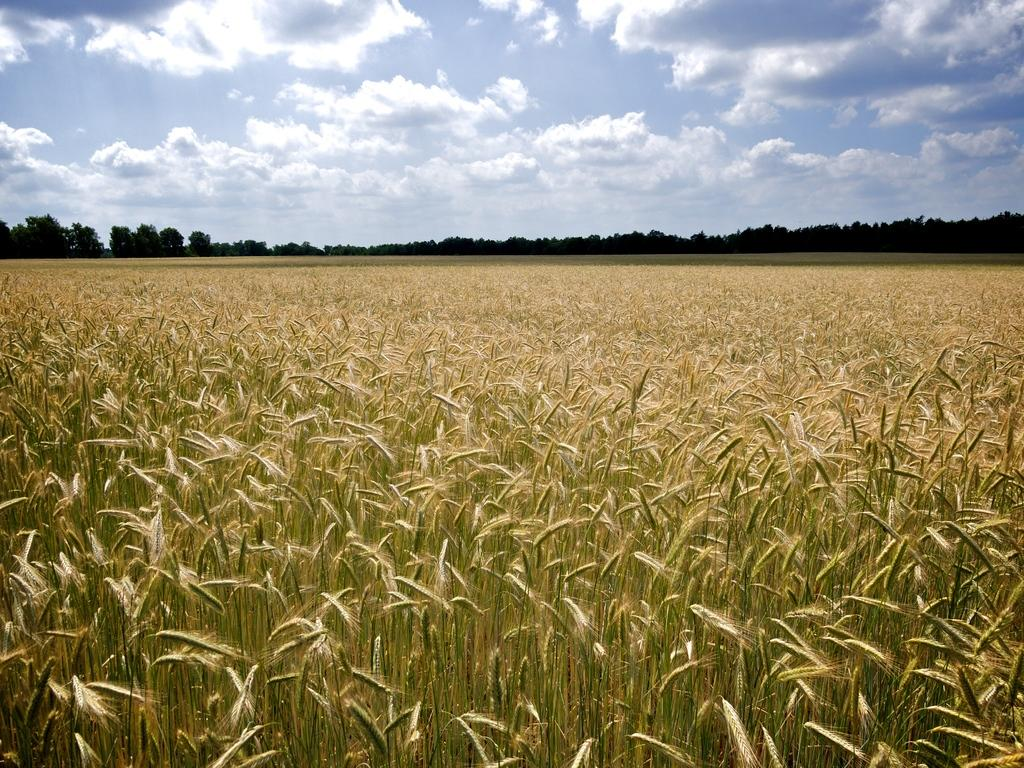What is the main subject in the foreground of the image? There is a farm field in the foreground of the image. What can be seen in the background of the image? There are trees in the background of the image. What is visible above the trees and farm field? The sky is visible in the image. What can be observed in the sky? Clouds are present in the sky. How many fingers are visible in the image? There are no fingers visible in the image, as it primarily features a farm field, trees, and the sky. 